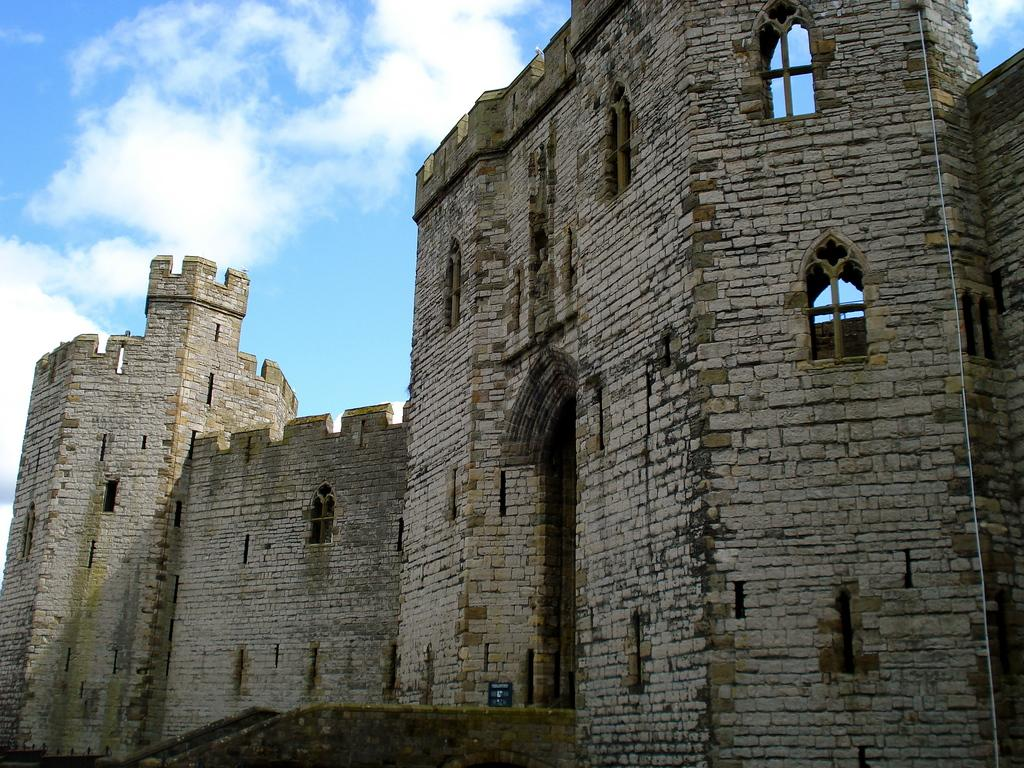What type of structure is in the image? There is a building in the image. What colors are used for the building are mentioned in the facts? The building is in gray and black colors. What can be seen in the background of the image? The sky is visible in the background of the image. What colors are mentioned for the sky? The sky is in blue and white colors. How much income does the building generate in the image? The facts provided do not mention any information about the building's income, so it cannot be determined from the image. 